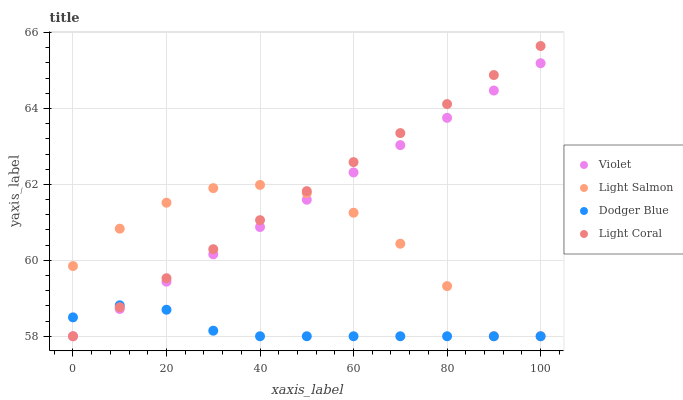Does Dodger Blue have the minimum area under the curve?
Answer yes or no. Yes. Does Light Coral have the maximum area under the curve?
Answer yes or no. Yes. Does Light Salmon have the minimum area under the curve?
Answer yes or no. No. Does Light Salmon have the maximum area under the curve?
Answer yes or no. No. Is Light Coral the smoothest?
Answer yes or no. Yes. Is Light Salmon the roughest?
Answer yes or no. Yes. Is Dodger Blue the smoothest?
Answer yes or no. No. Is Dodger Blue the roughest?
Answer yes or no. No. Does Light Coral have the lowest value?
Answer yes or no. Yes. Does Light Coral have the highest value?
Answer yes or no. Yes. Does Light Salmon have the highest value?
Answer yes or no. No. Does Violet intersect Light Coral?
Answer yes or no. Yes. Is Violet less than Light Coral?
Answer yes or no. No. Is Violet greater than Light Coral?
Answer yes or no. No. 